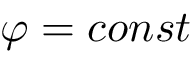Convert formula to latex. <formula><loc_0><loc_0><loc_500><loc_500>\varphi = c o n s t</formula> 